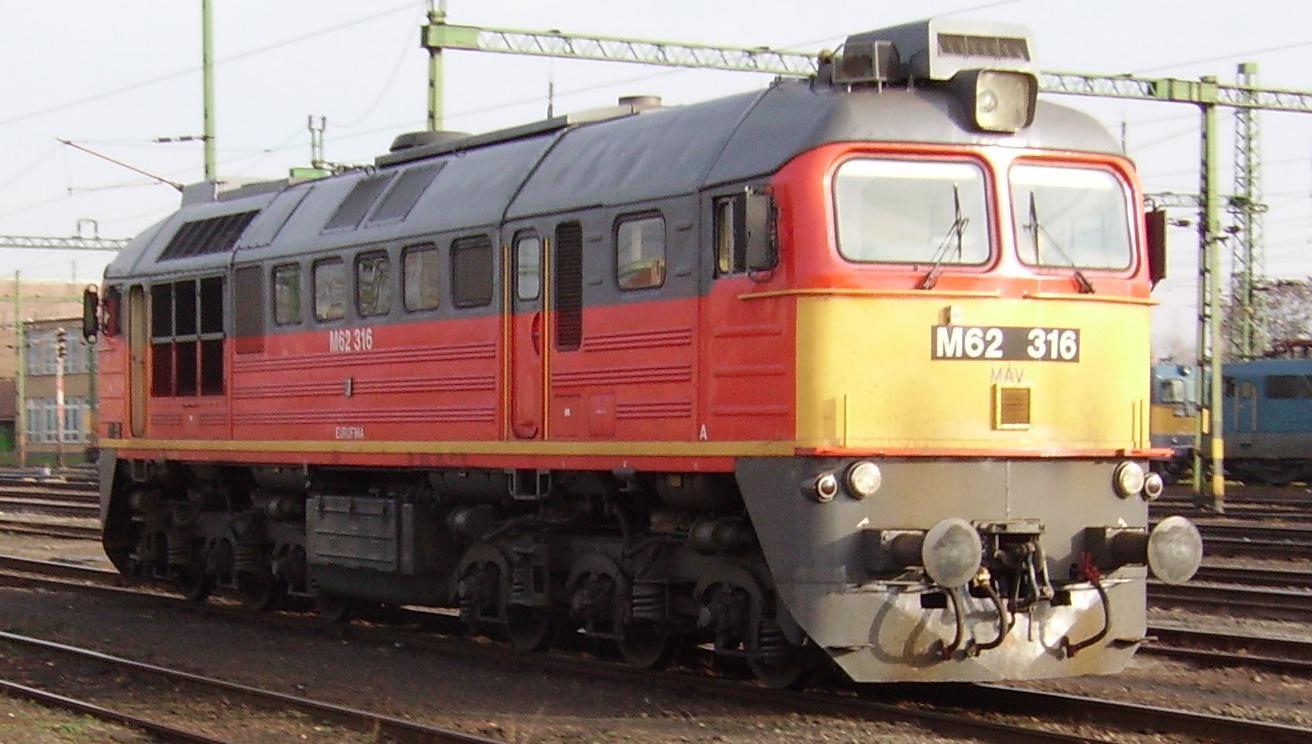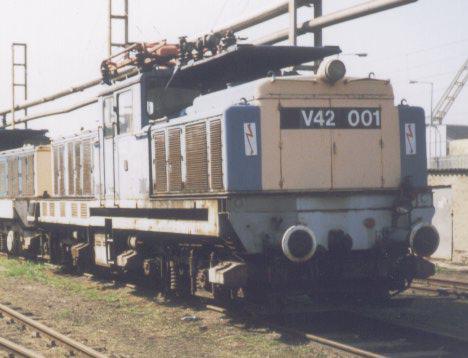The first image is the image on the left, the second image is the image on the right. Analyze the images presented: Is the assertion "The red train car is moving toward the right." valid? Answer yes or no. Yes. The first image is the image on the left, the second image is the image on the right. Assess this claim about the two images: "An image shows a reddish-orange train facing rightward.". Correct or not? Answer yes or no. Yes. 